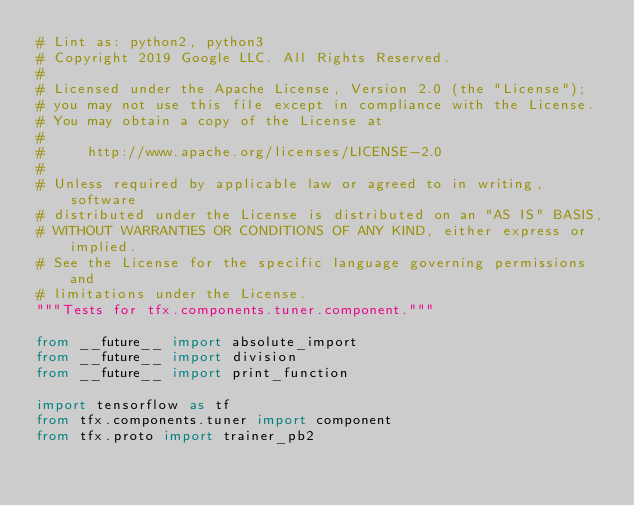<code> <loc_0><loc_0><loc_500><loc_500><_Python_># Lint as: python2, python3
# Copyright 2019 Google LLC. All Rights Reserved.
#
# Licensed under the Apache License, Version 2.0 (the "License");
# you may not use this file except in compliance with the License.
# You may obtain a copy of the License at
#
#     http://www.apache.org/licenses/LICENSE-2.0
#
# Unless required by applicable law or agreed to in writing, software
# distributed under the License is distributed on an "AS IS" BASIS,
# WITHOUT WARRANTIES OR CONDITIONS OF ANY KIND, either express or implied.
# See the License for the specific language governing permissions and
# limitations under the License.
"""Tests for tfx.components.tuner.component."""

from __future__ import absolute_import
from __future__ import division
from __future__ import print_function

import tensorflow as tf
from tfx.components.tuner import component
from tfx.proto import trainer_pb2</code> 